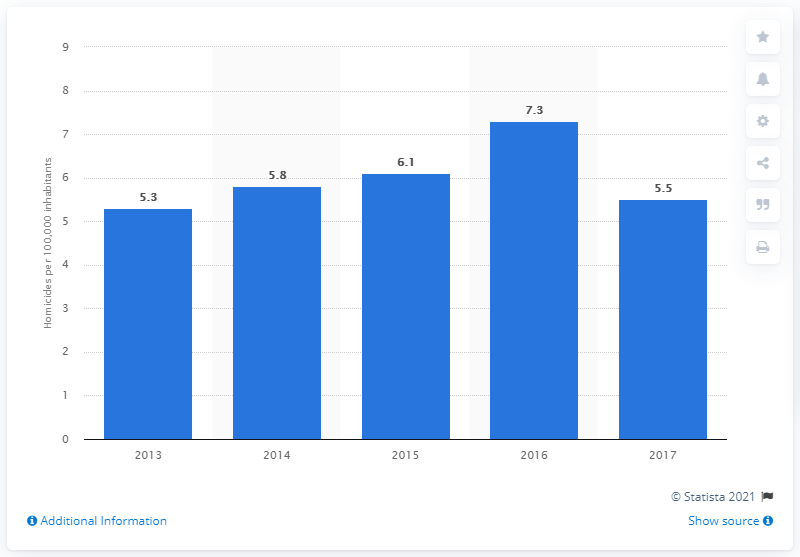Give some essential details in this illustration. The previous murder rate in Suriname was 7.3 per 100,000 residents. The previous murder rate in Suriname was 7.3 per 100,000 inhabitants. 